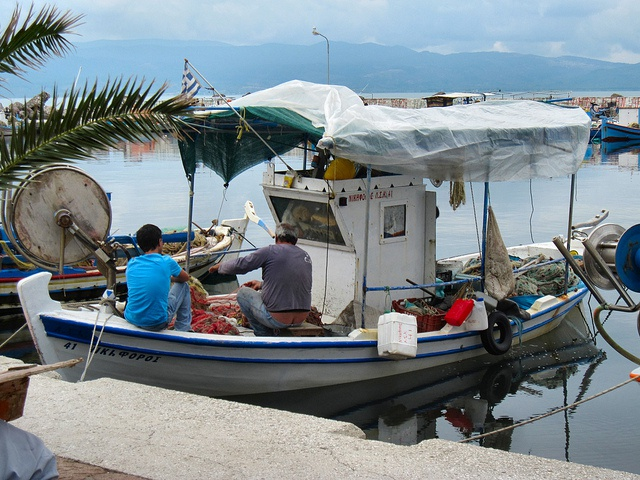Describe the objects in this image and their specific colors. I can see boat in lightblue, gray, black, darkgray, and lightgray tones, people in lightblue, gray, black, and maroon tones, people in lightblue, blue, and black tones, boat in lightblue, gray, black, and ivory tones, and boat in lightblue, black, blue, and darkblue tones in this image. 